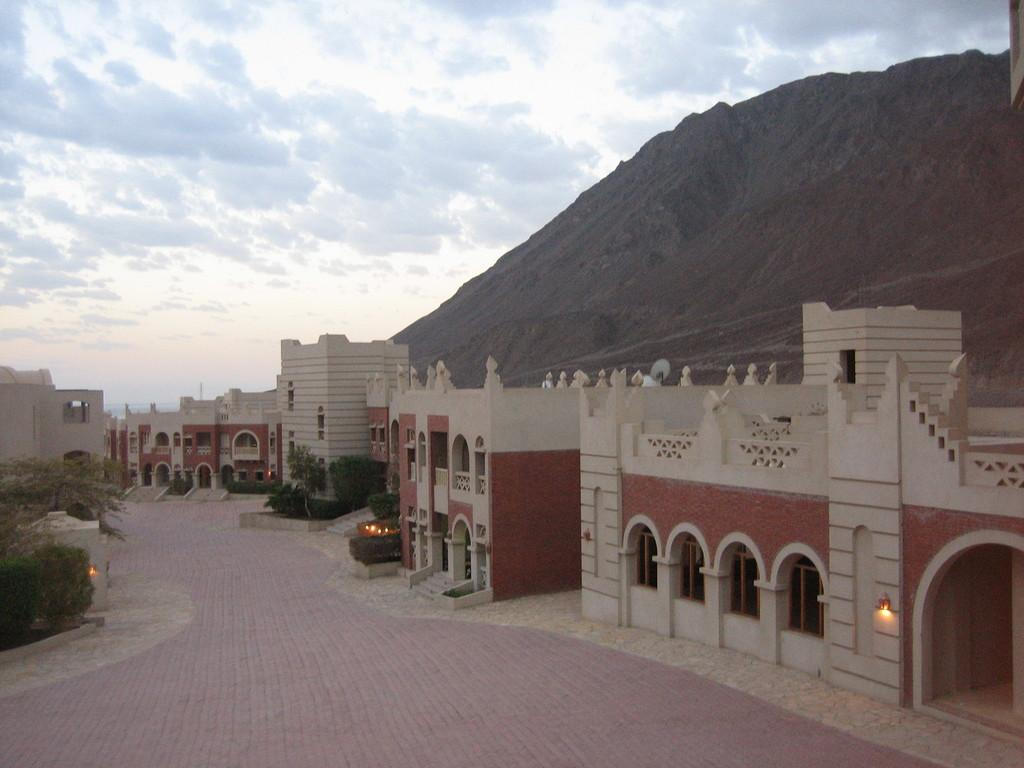What type of structures can be seen in the image? There are buildings in the image. What other elements are present in the image besides buildings? There are plants, lights, and a hill on the right side of the image. How would you describe the sky in the image? The sky is cloudy in the image. Can you hear the ear playing music at the party in the image? There is no party or ear present in the image; it features buildings, plants, lights, and a cloudy sky. Are there any visible teeth on the toothbrush in the image? There is no toothbrush or tooth present in the image; it features buildings, plants, lights, a hill, and a cloudy sky. 